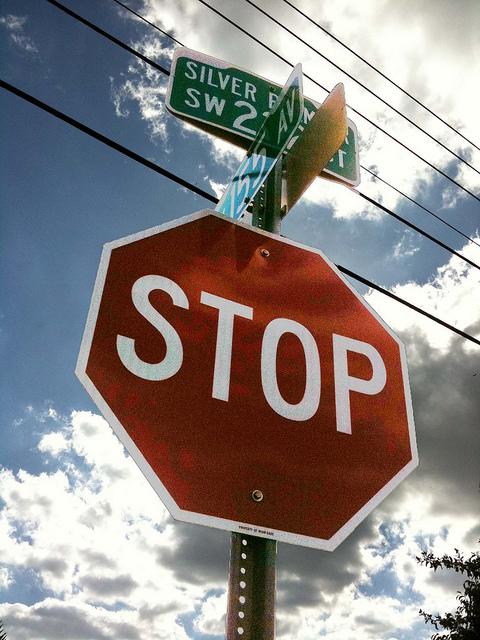Are there clouds?
Answer briefly. Yes. Is the sun shining?
Quick response, please. Yes. How many signs are on post?
Quick response, please. 4. 